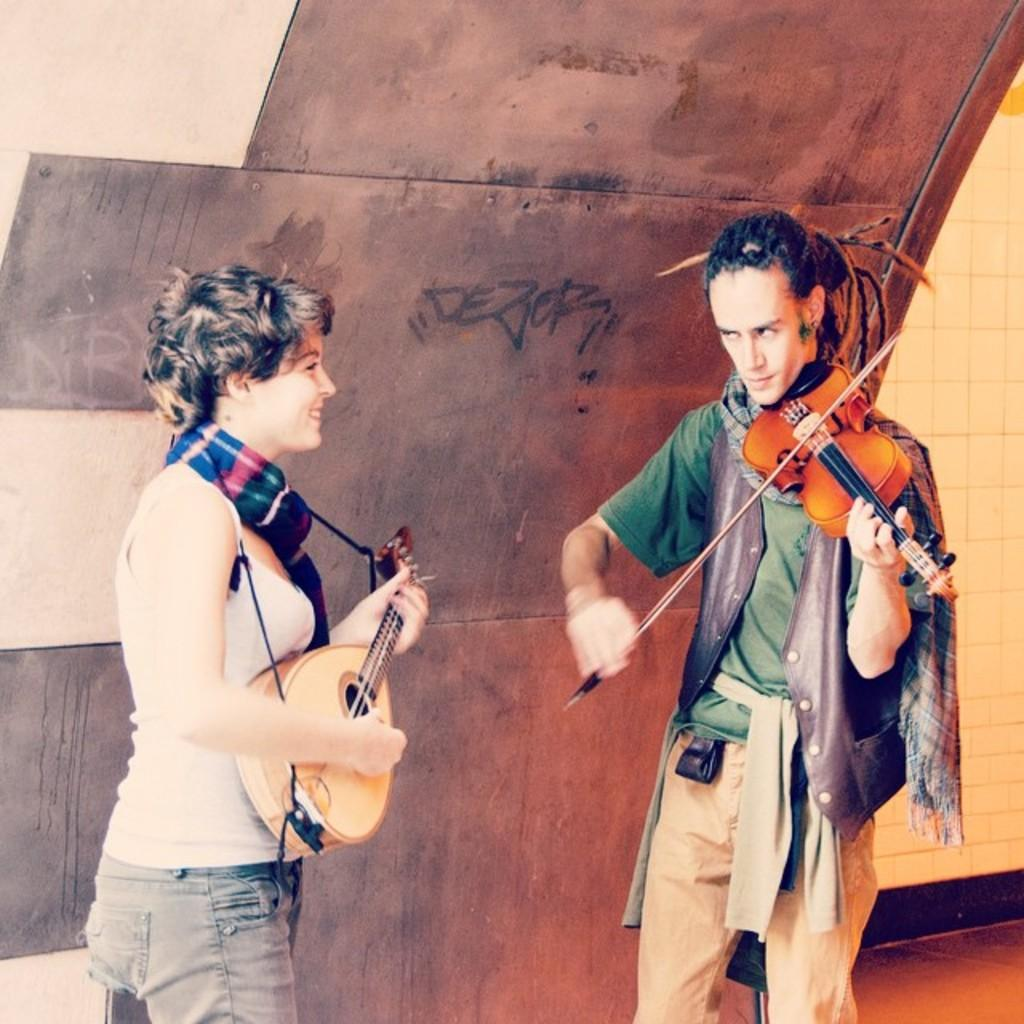Who are the people in the image? There is a woman and a man in the image. What is the man doing in the image? The man is playing a guitar. What can be seen in the background of the image? There is a board and a wall in the background of the image. What type of loaf is the woman holding in the image? There is no loaf present in the image; the woman is not holding anything. 